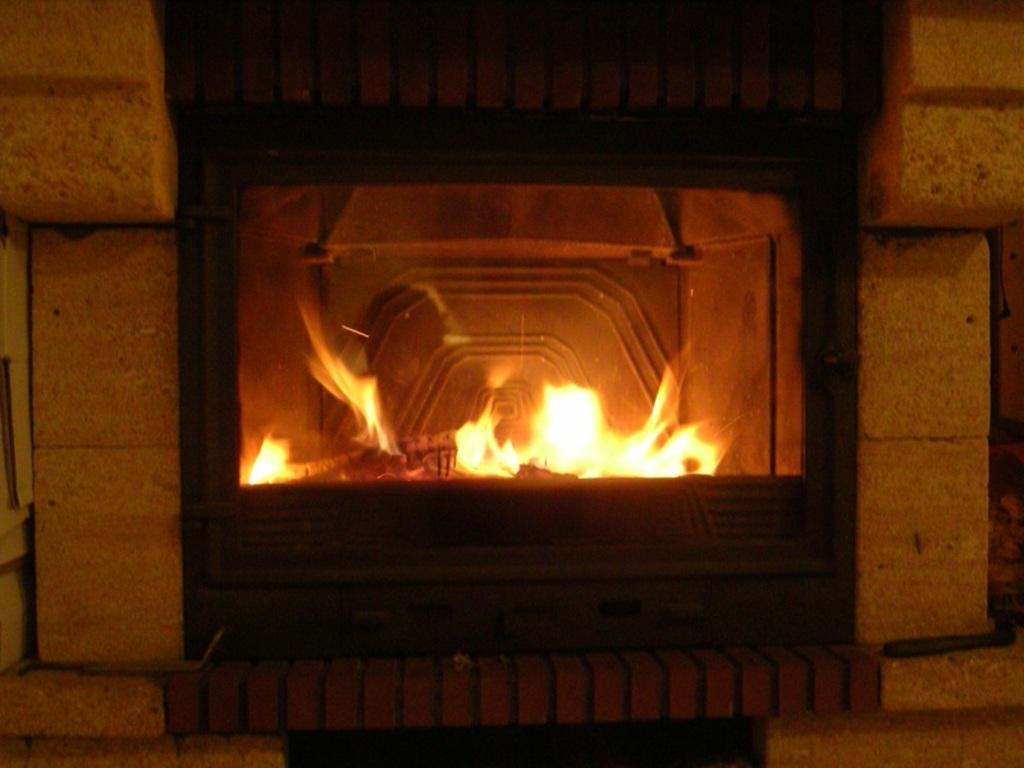What can be seen on the wall in the image? There is a fireplace on the wall in the image. What is happening inside the fireplace? There is a flame inside the fireplace. What type of cracker is being used to extinguish the flame in the image? There is no cracker present in the image, and the flame is not being extinguished. 